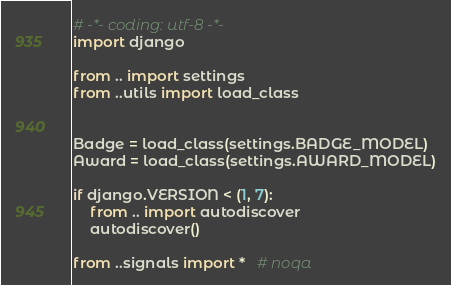<code> <loc_0><loc_0><loc_500><loc_500><_Python_># -*- coding: utf-8 -*-
import django

from .. import settings
from ..utils import load_class


Badge = load_class(settings.BADGE_MODEL)
Award = load_class(settings.AWARD_MODEL)

if django.VERSION < (1, 7):
    from .. import autodiscover
    autodiscover()

from ..signals import *   # noqa
</code> 